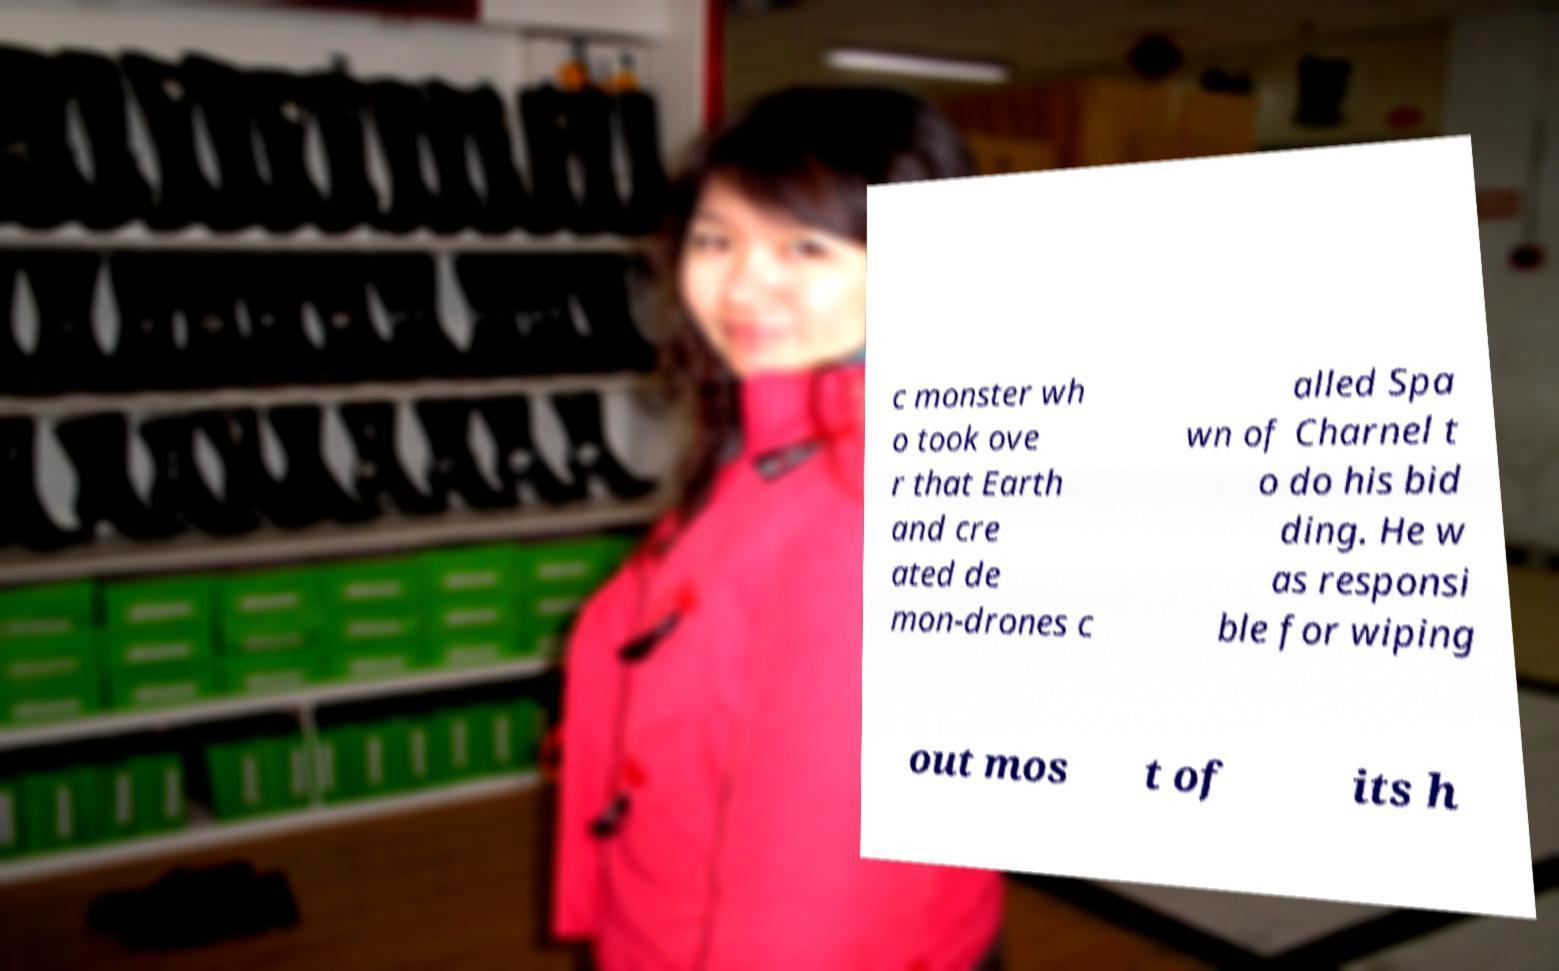There's text embedded in this image that I need extracted. Can you transcribe it verbatim? c monster wh o took ove r that Earth and cre ated de mon-drones c alled Spa wn of Charnel t o do his bid ding. He w as responsi ble for wiping out mos t of its h 